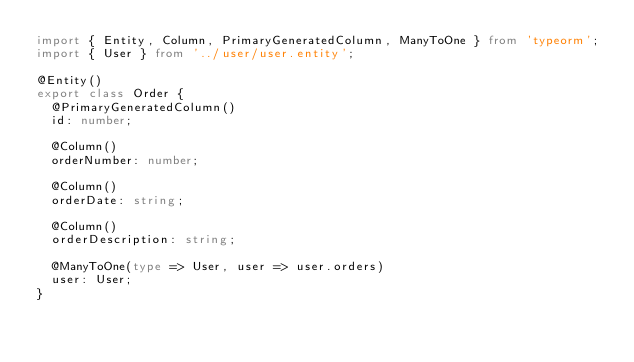Convert code to text. <code><loc_0><loc_0><loc_500><loc_500><_TypeScript_>import { Entity, Column, PrimaryGeneratedColumn, ManyToOne } from 'typeorm';
import { User } from '../user/user.entity';

@Entity()
export class Order {
	@PrimaryGeneratedColumn()
	id: number;

	@Column()
	orderNumber: number;

	@Column()
	orderDate: string;

	@Column()
	orderDescription: string;

	@ManyToOne(type => User, user => user.orders)
	user: User;
}
</code> 